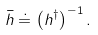<formula> <loc_0><loc_0><loc_500><loc_500>\bar { h } \doteq \left ( h ^ { \dagger } \right ) ^ { - 1 } .</formula> 